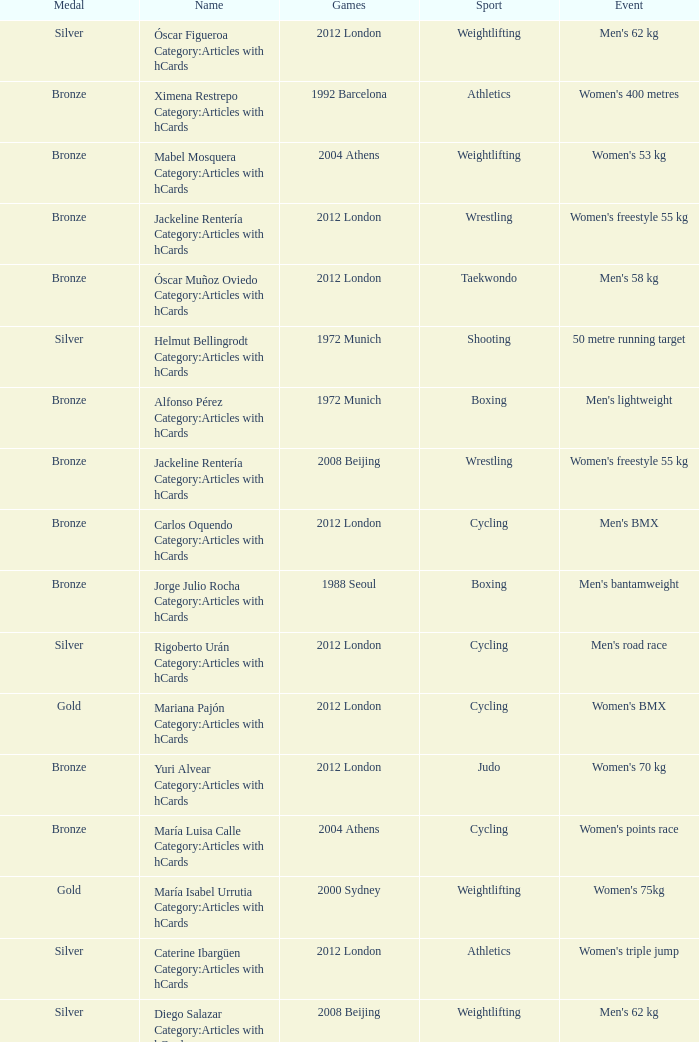What wrestling event was participated in during the 2008 Beijing games? Women's freestyle 55 kg. 